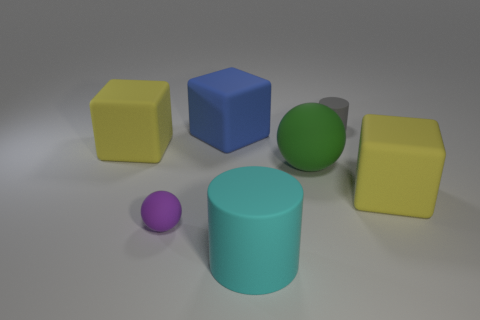Add 1 yellow rubber cubes. How many objects exist? 8 Subtract all cylinders. How many objects are left? 5 Subtract all yellow matte objects. Subtract all cyan cylinders. How many objects are left? 4 Add 6 large yellow things. How many large yellow things are left? 8 Add 3 small red objects. How many small red objects exist? 3 Subtract 1 green balls. How many objects are left? 6 